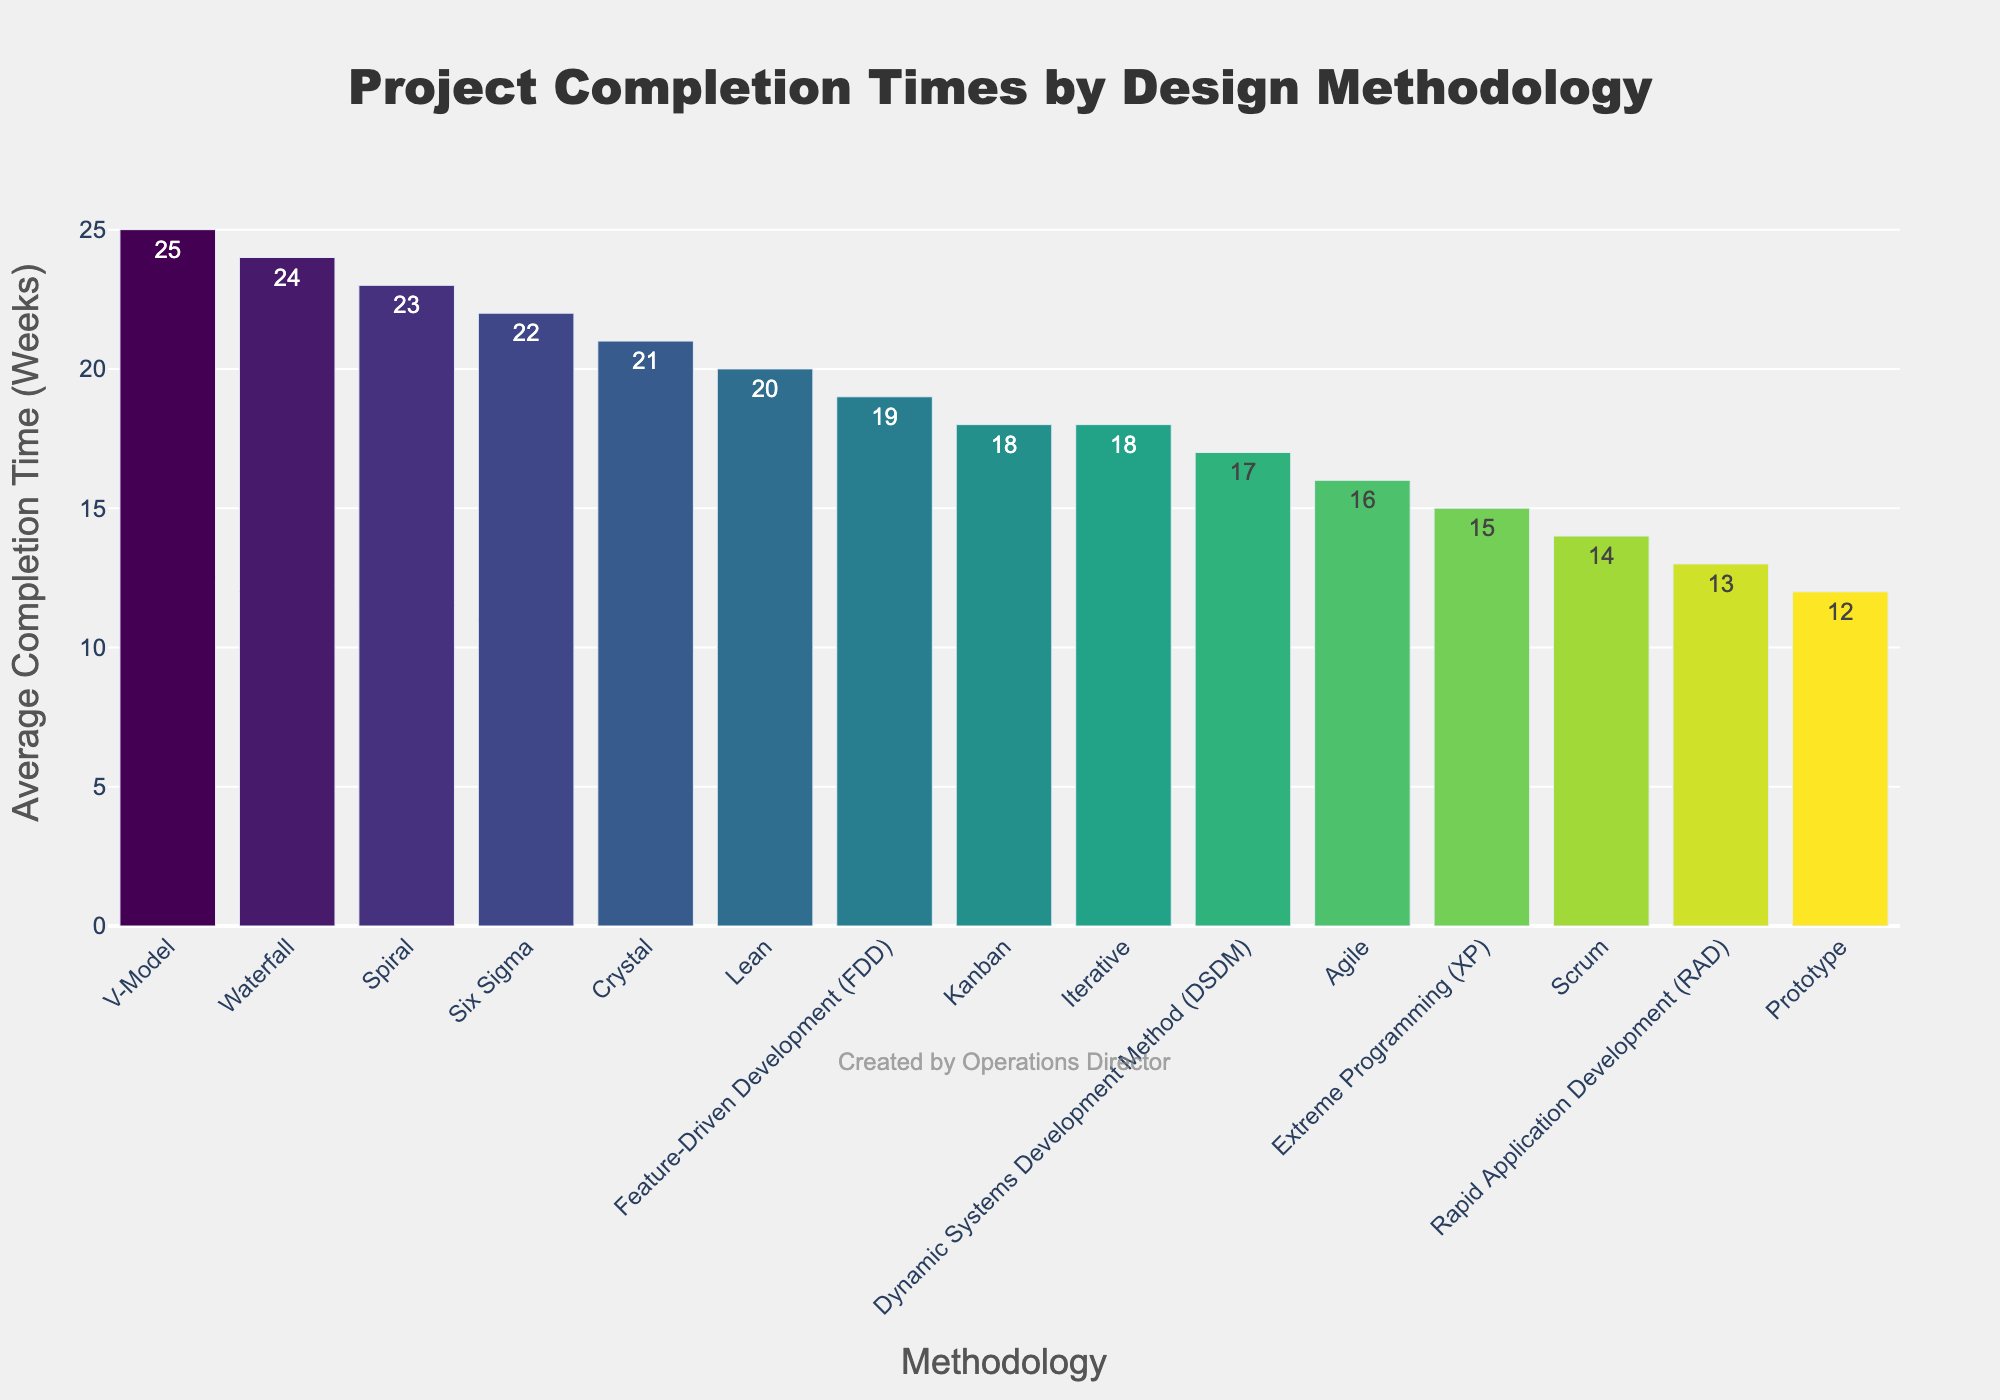What is the average completion time for the Prototype methodology? The bar for the Prototype methodology shows an average completion time of 12 weeks.
Answer: 12 Which methodology has the longest project completion time? The V-Model methodology has the tallest bar, indicating the longest project completion time at 25 weeks.
Answer: V-Model How much shorter is the completion time for Agile compared to Waterfall? The Waterfall methodology has a completion time of 24 weeks, and Agile has 16 weeks. The difference is 24 - 16 = 8 weeks.
Answer: 8 weeks Identify the methodology with the shortest project completion time and its value. The shortest bar corresponds to the Prototype methodology at 12 weeks.
Answer: Prototype, 12 weeks Between Scrum and Kanban, which has a shorter average completion time and by how much? Scrum has a completion time of 14 weeks, and Kanban has 18 weeks. The difference is 18 - 14 = 4 weeks. Scrum is shorter by 4 weeks.
Answer: Scrum, 4 weeks Which three methodologies fall in the middle of the completion times and what are their average times? The middle methodologies in the sorted list are Crystal (21 weeks), Six Sigma (22 weeks), and Spiral (23 weeks).
Answer: Crystal: 21 weeks, Six Sigma: 22 weeks, Spiral: 23 weeks Compare the completion times of Lean and Crystal. Which is faster and by how much? Lean has a completion time of 20 weeks, and Crystal has 21 weeks. The difference is 21 - 20 = 1 week. Lean is faster by 1 week.
Answer: Lean, 1 week What is the total average completion time for Agile, Scrum, and Kanban methodologies together? Agile: 16 weeks, Scrum: 14 weeks, Kanban: 18 weeks. Sum them up: 16 + 14 + 18 = 48 weeks.
Answer: 48 weeks Which methodology has a completion time closest to the median of all the methodologies, and what is the median value? The sorted list of completion times is: 12, 13, 14, 15, 16, 17, 18, 18, 19, 20, 21, 22, 23, 24, 25. Median value is the average of 17 and 18, which is 17.5. DSDM and Iterative are closest, both at 18 weeks.
Answer: DSDM, Iterative, 18 weeks What is the range of the average completion times across all methodologies? The shortest average completion time is 12 weeks (Prototype), and the longest is 25 weeks (V-Model). The range is 25 - 12 = 13 weeks.
Answer: 13 weeks 